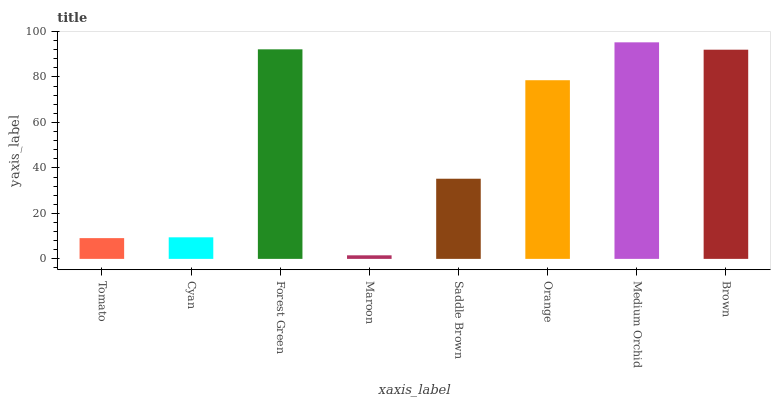Is Cyan the minimum?
Answer yes or no. No. Is Cyan the maximum?
Answer yes or no. No. Is Cyan greater than Tomato?
Answer yes or no. Yes. Is Tomato less than Cyan?
Answer yes or no. Yes. Is Tomato greater than Cyan?
Answer yes or no. No. Is Cyan less than Tomato?
Answer yes or no. No. Is Orange the high median?
Answer yes or no. Yes. Is Saddle Brown the low median?
Answer yes or no. Yes. Is Brown the high median?
Answer yes or no. No. Is Brown the low median?
Answer yes or no. No. 